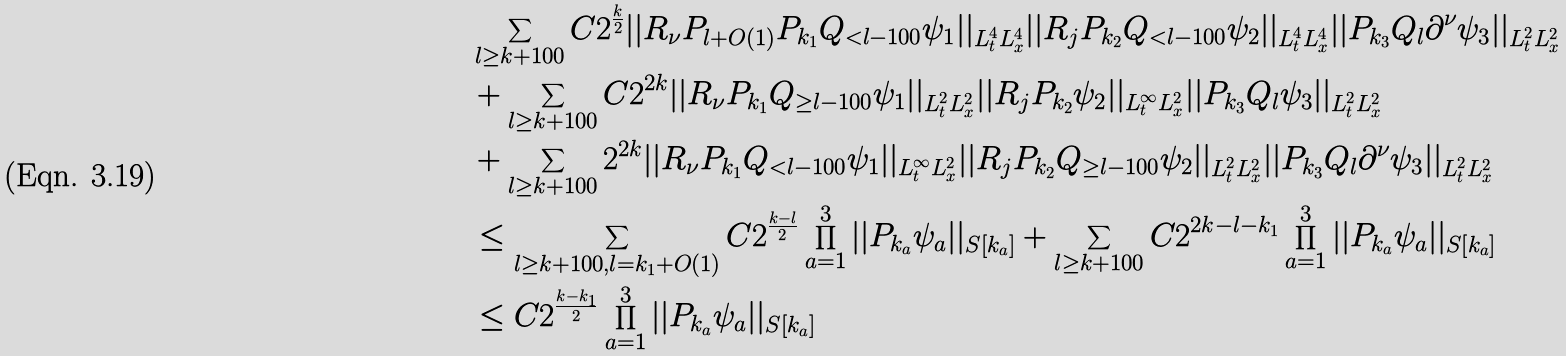Convert formula to latex. <formula><loc_0><loc_0><loc_500><loc_500>& \sum _ { l \geq k + 1 0 0 } C 2 ^ { \frac { k } { 2 } } | | R _ { \nu } P _ { l + O ( 1 ) } P _ { k _ { 1 } } Q _ { < l - 1 0 0 } \psi _ { 1 } | | _ { L _ { t } ^ { 4 } L _ { x } ^ { 4 } } | | R _ { j } P _ { k _ { 2 } } Q _ { < l - 1 0 0 } \psi _ { 2 } | | _ { L _ { t } ^ { 4 } L _ { x } ^ { 4 } } | | P _ { k _ { 3 } } Q _ { l } \partial ^ { \nu } \psi _ { 3 } | | _ { L _ { t } ^ { 2 } L _ { x } ^ { 2 } } \\ & + \sum _ { l \geq k + 1 0 0 } C 2 ^ { 2 k } | | R _ { \nu } P _ { k _ { 1 } } Q _ { \geq l - 1 0 0 } \psi _ { 1 } | | _ { L _ { t } ^ { 2 } L _ { x } ^ { 2 } } | | R _ { j } P _ { k _ { 2 } } \psi _ { 2 } | | _ { L _ { t } ^ { \infty } L _ { x } ^ { 2 } } | | P _ { k _ { 3 } } Q _ { l } \psi _ { 3 } | | _ { L _ { t } ^ { 2 } L _ { x } ^ { 2 } } \\ & + \sum _ { l \geq k + 1 0 0 } 2 ^ { 2 k } | | R _ { \nu } P _ { k _ { 1 } } Q _ { < l - 1 0 0 } \psi _ { 1 } | | _ { L _ { t } ^ { \infty } L _ { x } ^ { 2 } } | | R _ { j } P _ { k _ { 2 } } Q _ { \geq l - 1 0 0 } \psi _ { 2 } | | _ { L _ { t } ^ { 2 } L _ { x } ^ { 2 } } | | P _ { k _ { 3 } } Q _ { l } \partial ^ { \nu } \psi _ { 3 } | | _ { L _ { t } ^ { 2 } L _ { x } ^ { 2 } } \\ & \leq \sum _ { l \geq k + 1 0 0 , l = k _ { 1 } + O ( 1 ) } C 2 ^ { \frac { k - l } { 2 } } \prod _ { a = 1 } ^ { 3 } | | P _ { k _ { a } } \psi _ { a } | | _ { S [ k _ { a } ] } + \sum _ { l \geq k + 1 0 0 } C 2 ^ { 2 k - l - k _ { 1 } } \prod _ { a = 1 } ^ { 3 } | | P _ { k _ { a } } \psi _ { a } | | _ { S [ k _ { a } ] } \\ & \leq C 2 ^ { \frac { k - k _ { 1 } } { 2 } } \prod _ { a = 1 } ^ { 3 } | | P _ { k _ { a } } \psi _ { a } | | _ { S [ k _ { a } ] } \\</formula> 